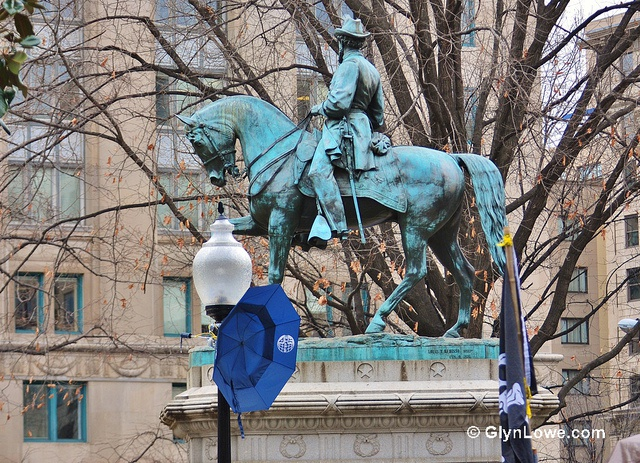Describe the objects in this image and their specific colors. I can see horse in darkgray, black, teal, lightblue, and gray tones and umbrella in darkgray, blue, navy, darkblue, and black tones in this image. 